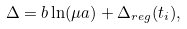<formula> <loc_0><loc_0><loc_500><loc_500>\Delta = b \ln ( \mu a ) + \Delta _ { r e g } ( t _ { i } ) ,</formula> 